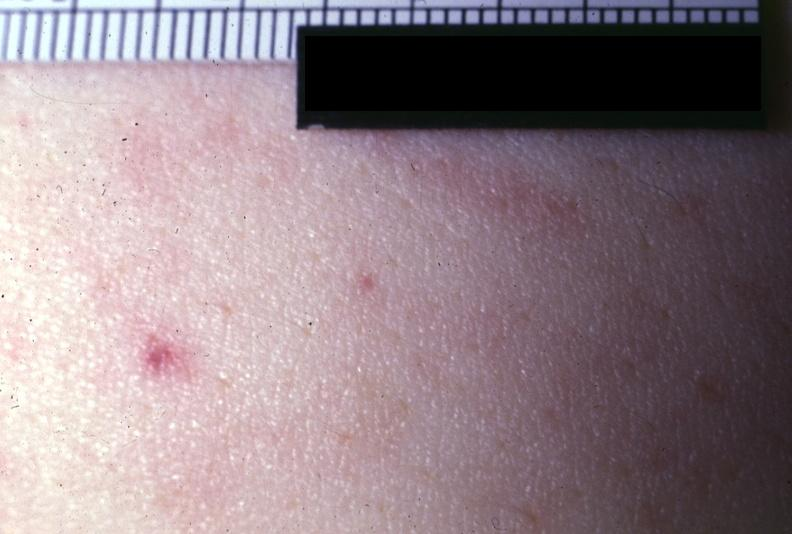s antitrypsin present?
Answer the question using a single word or phrase. No 